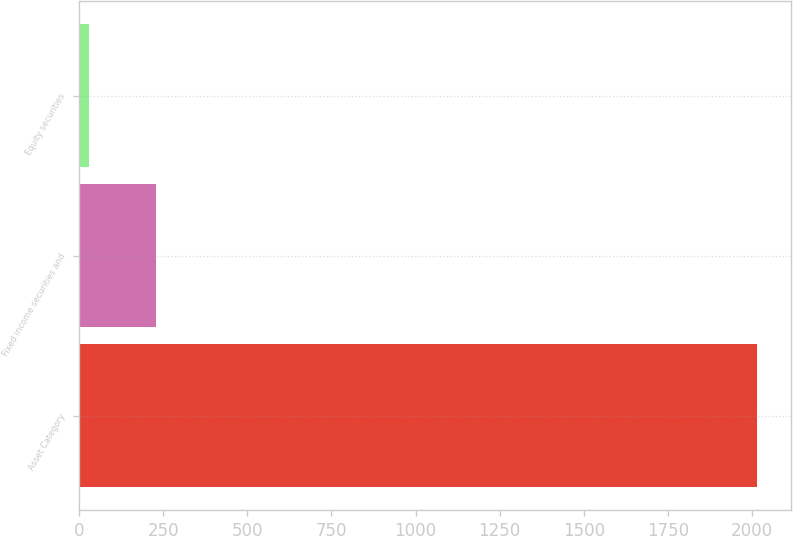<chart> <loc_0><loc_0><loc_500><loc_500><bar_chart><fcel>Asset Category<fcel>Fixed income securities and<fcel>Equity securities<nl><fcel>2015<fcel>228.5<fcel>30<nl></chart> 